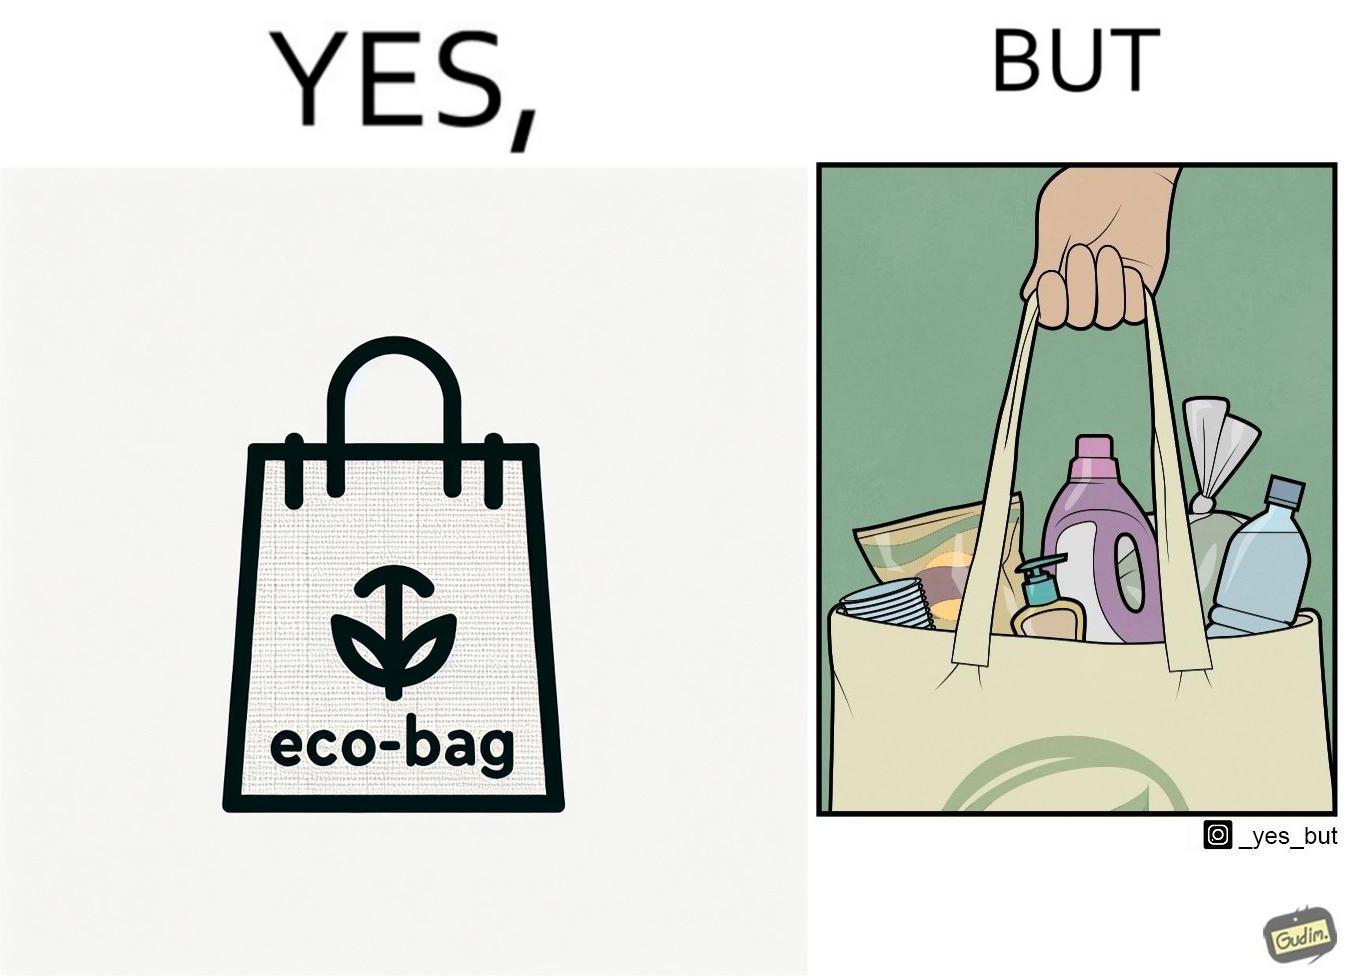Compare the left and right sides of this image. In the left part of the image: a bag with text "eco-bag" on it, probably made up of some eco-friendly materials like cotton or jute In the right part of the image: a person carrying different products inside plastic containers or plastic wrapping in a carry bag 